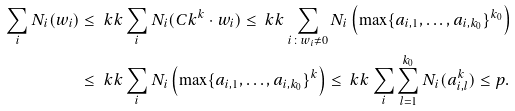<formula> <loc_0><loc_0><loc_500><loc_500>\sum _ { i } N _ { i } ( w _ { i } ) & \leq \ k k \sum _ { i } N _ { i } ( C k ^ { k } \cdot w _ { i } ) \leq \ k k \sum _ { i \colon w _ { i } \neq 0 } N _ { i } \left ( \max \{ a _ { i , 1 } , \dots , a _ { i , k _ { 0 } } \} ^ { k _ { 0 } } \right ) \\ & \leq \ k k \sum _ { i } N _ { i } \left ( \max \{ a _ { i , 1 } , \dots , a _ { i , k _ { 0 } } \} ^ { k } \right ) \leq \ k k \sum _ { i } \sum _ { l = 1 } ^ { k _ { 0 } } N _ { i } ( a ^ { k } _ { i , l } ) \leq p .</formula> 